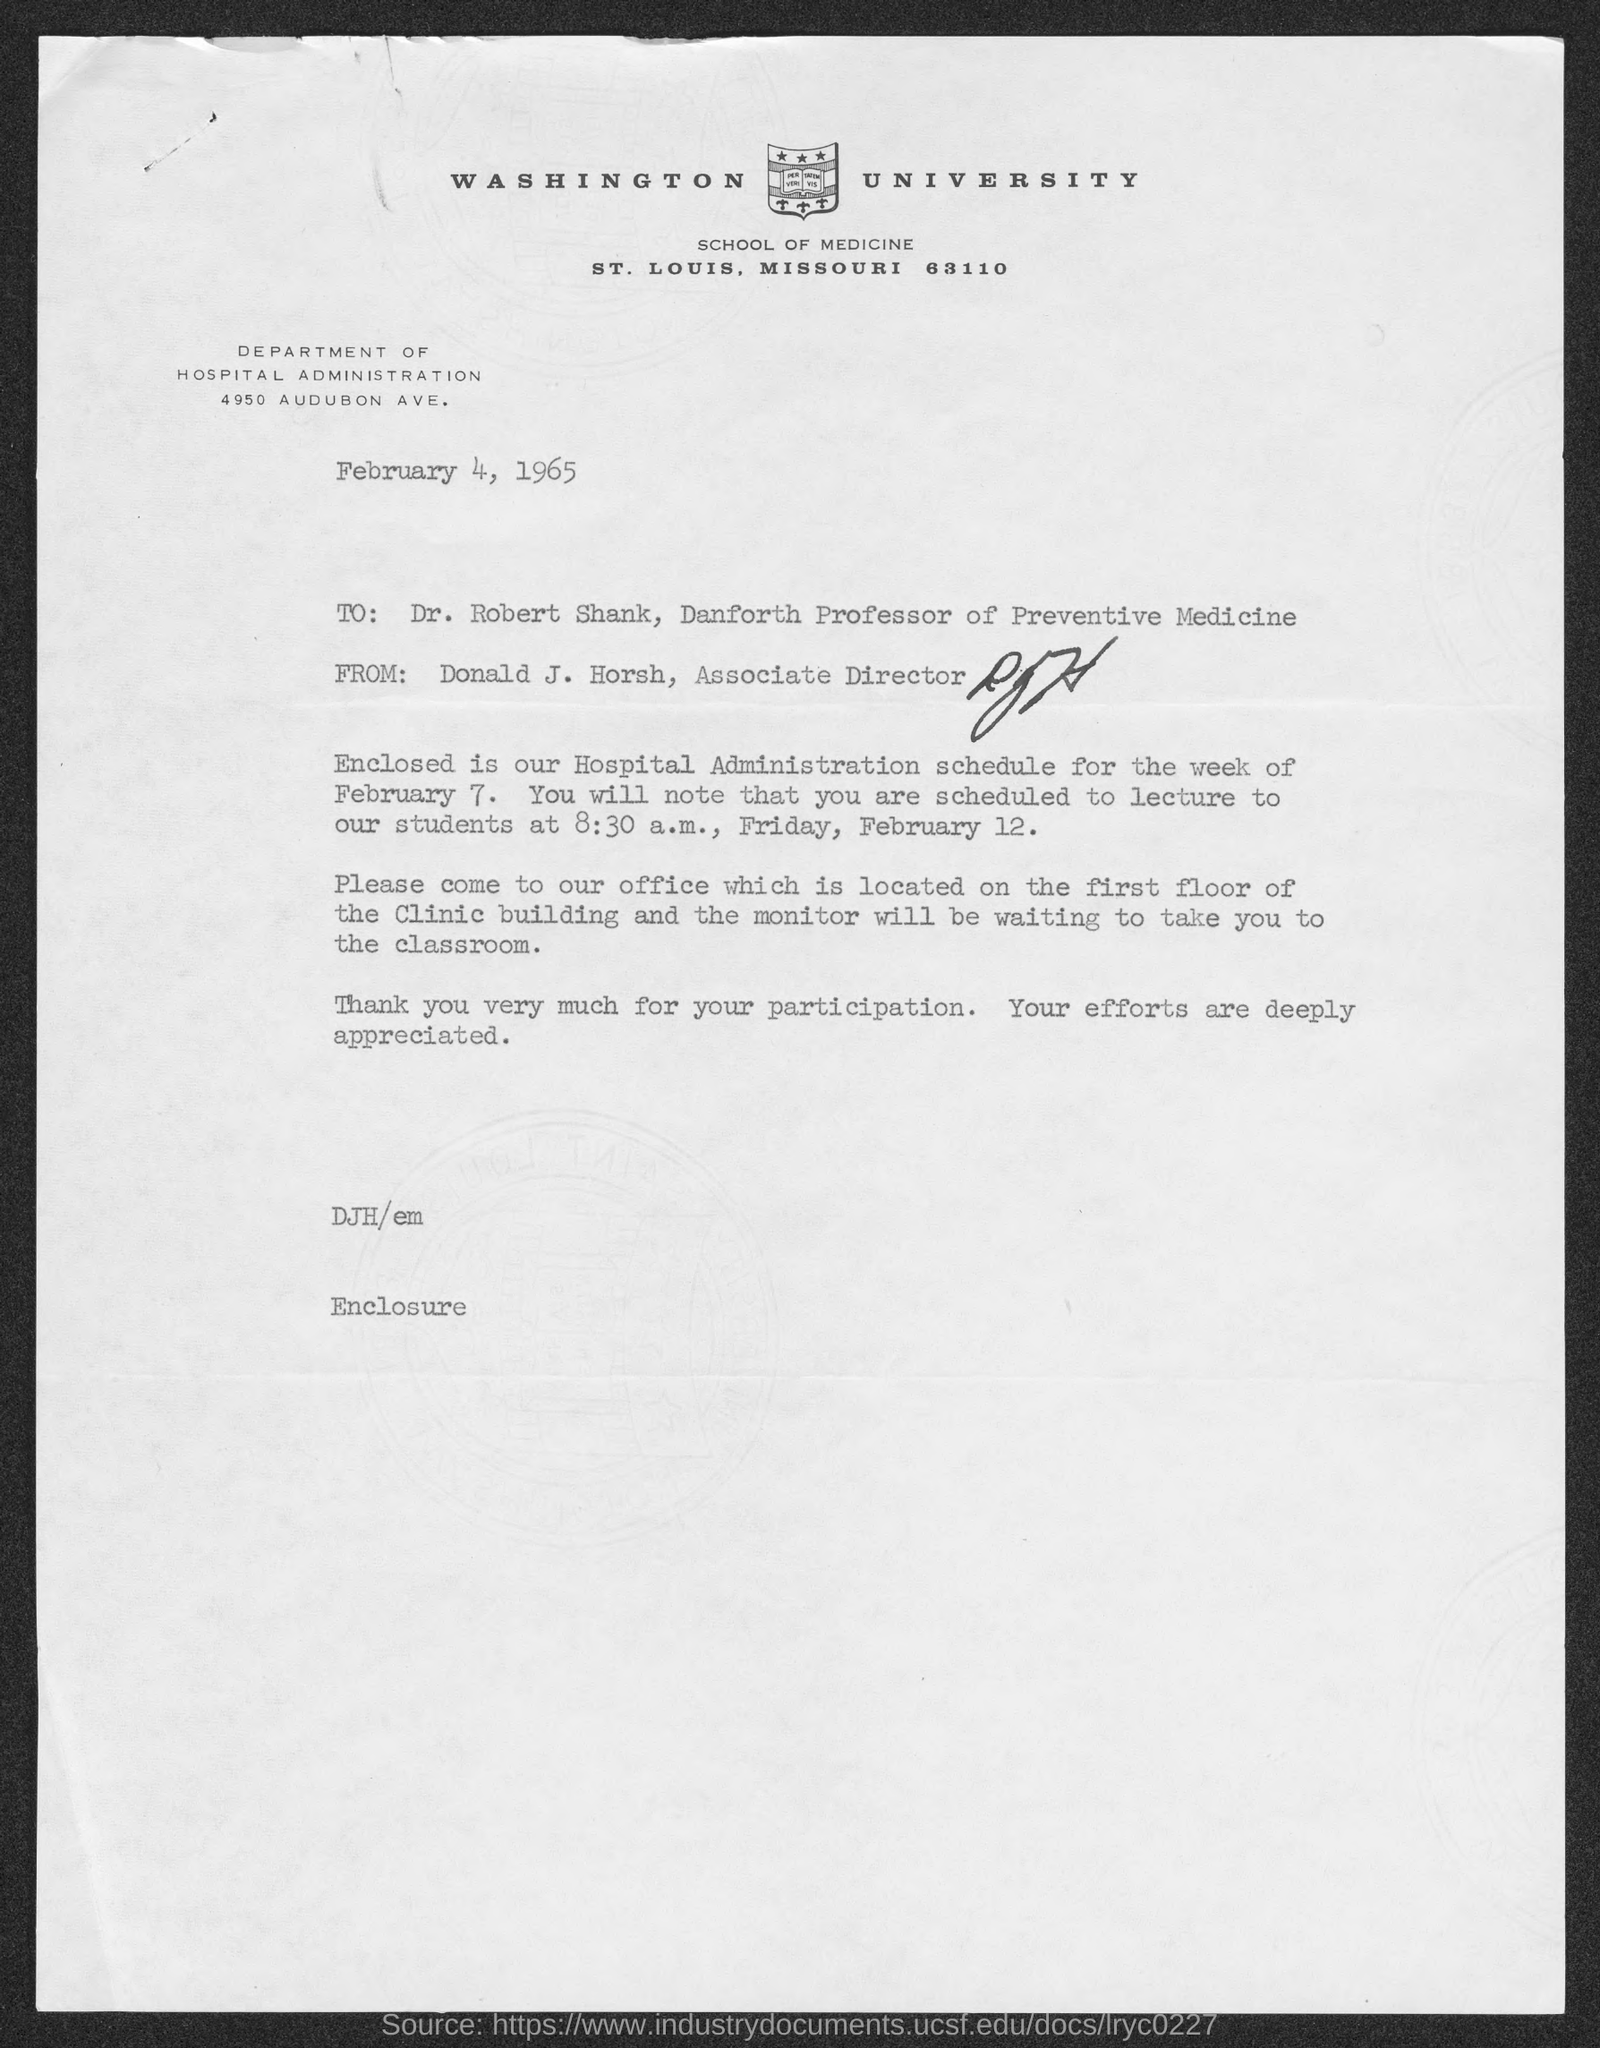Point out several critical features in this image. The lecture is scheduled for Friday, February 12, at 8:30 a.m. Donald J. Horsh is currently the Associate Director. The author of this letter is Donald J. Horsh. The street address of the Department of Hospital Administration is located at 4950 Audubon Ave. Dr. Robert Shank holds the position of Professor of Preventive Medicine. 